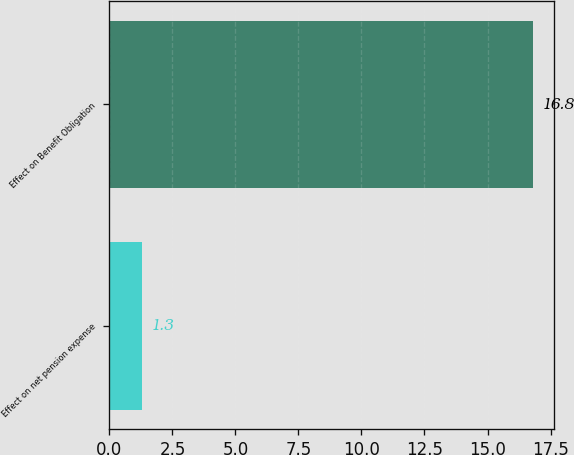Convert chart. <chart><loc_0><loc_0><loc_500><loc_500><bar_chart><fcel>Effect on net pension expense<fcel>Effect on Benefit Obligation<nl><fcel>1.3<fcel>16.8<nl></chart> 